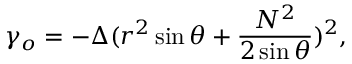<formula> <loc_0><loc_0><loc_500><loc_500>\gamma _ { o } = - \Delta ( r ^ { 2 } \sin \theta + \frac { N ^ { 2 } } { 2 \sin \theta } ) ^ { 2 } ,</formula> 